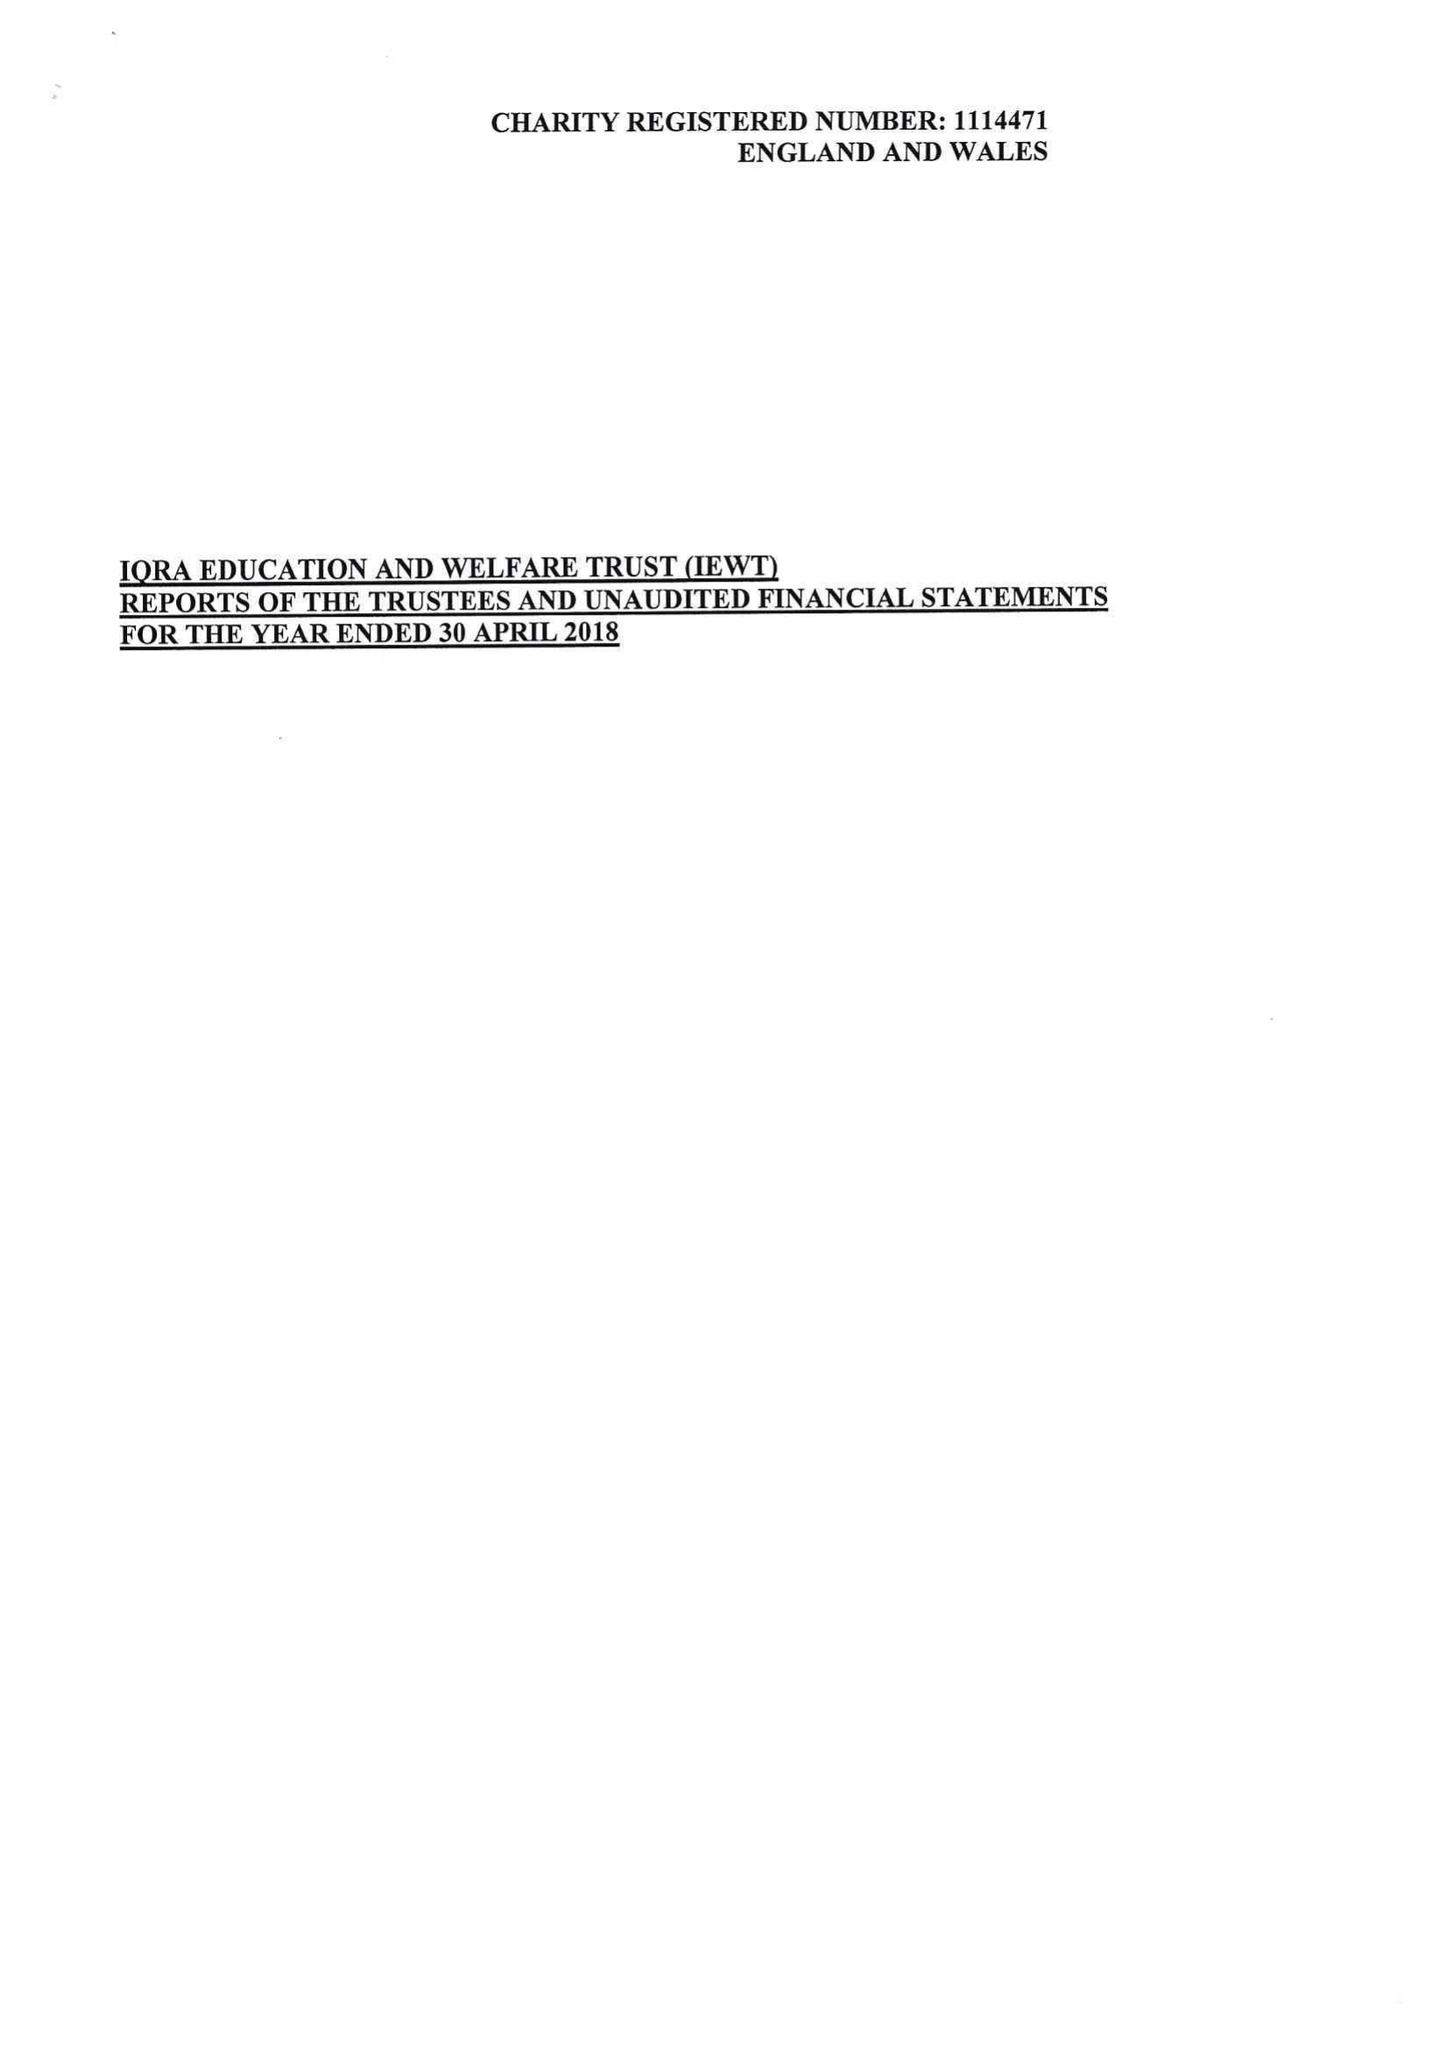What is the value for the income_annually_in_british_pounds?
Answer the question using a single word or phrase. 120807.00 